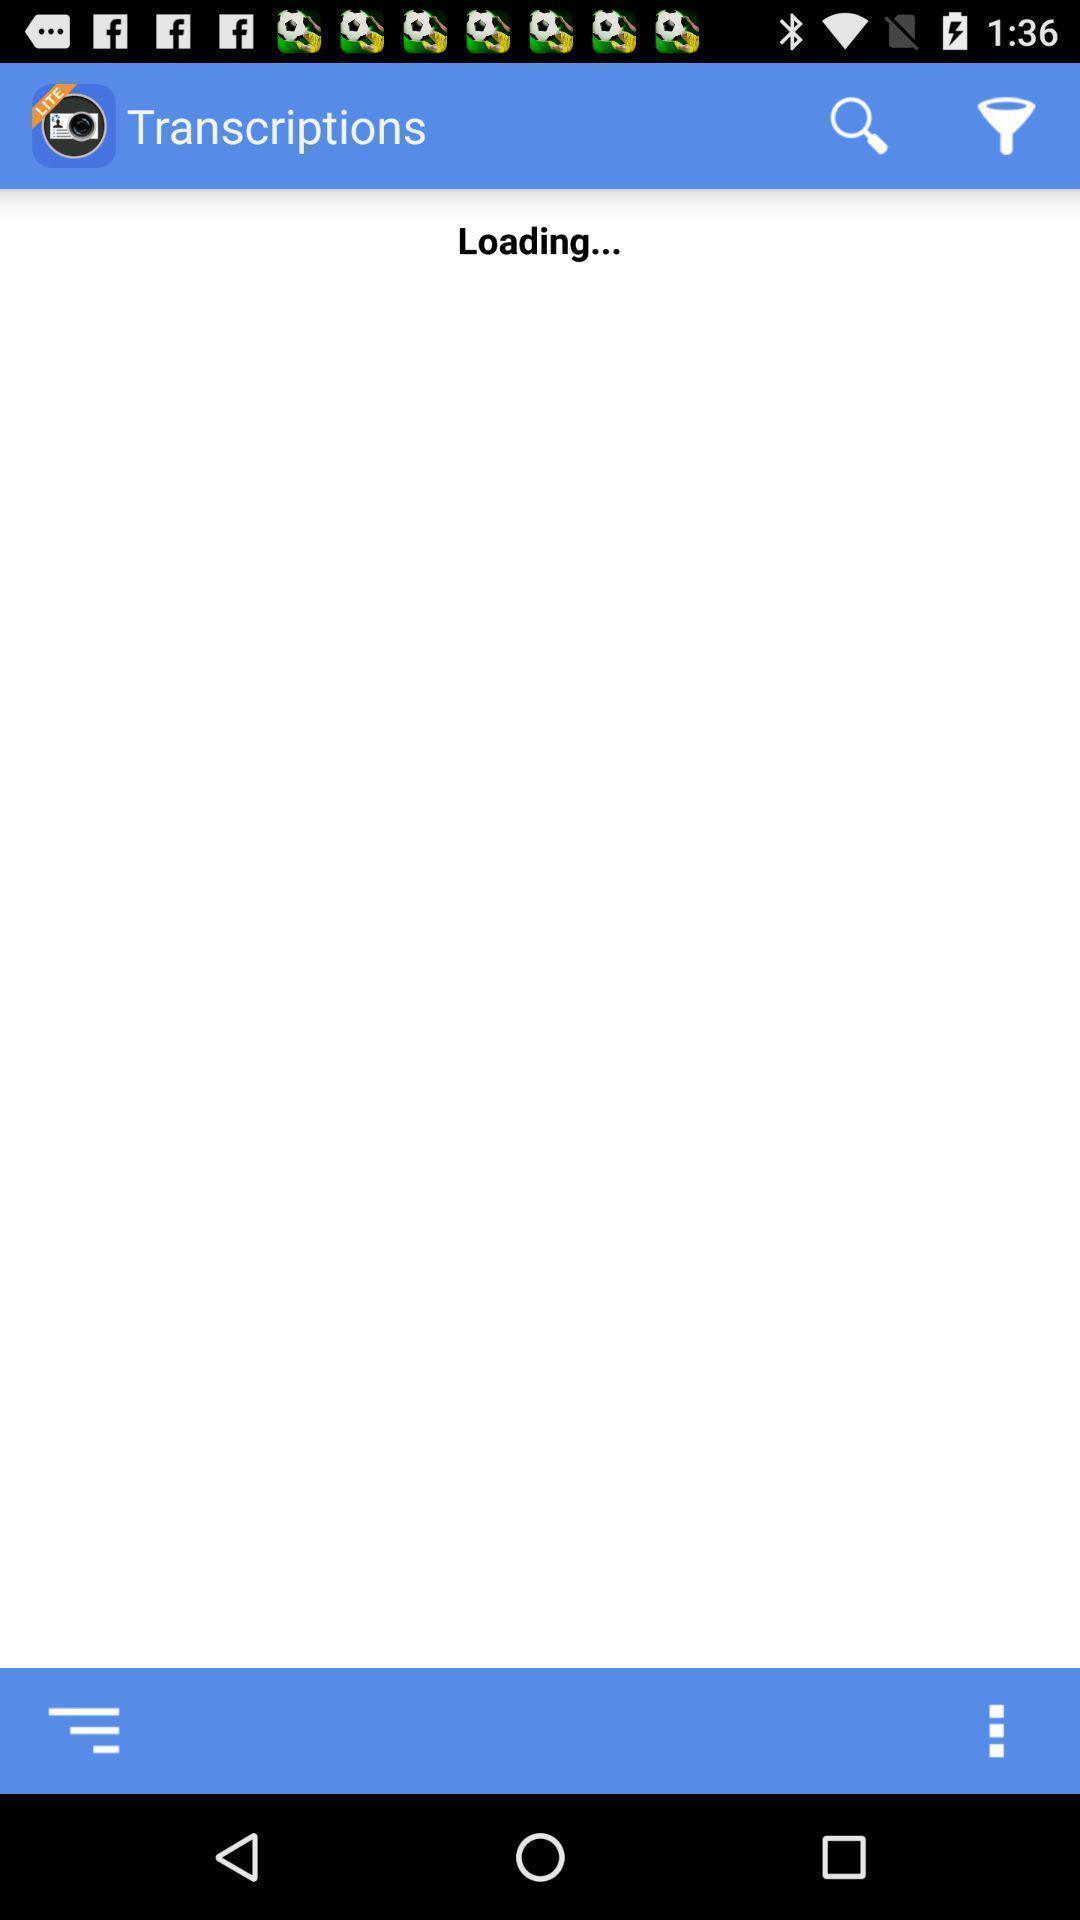What details can you identify in this image? Transcription page. 